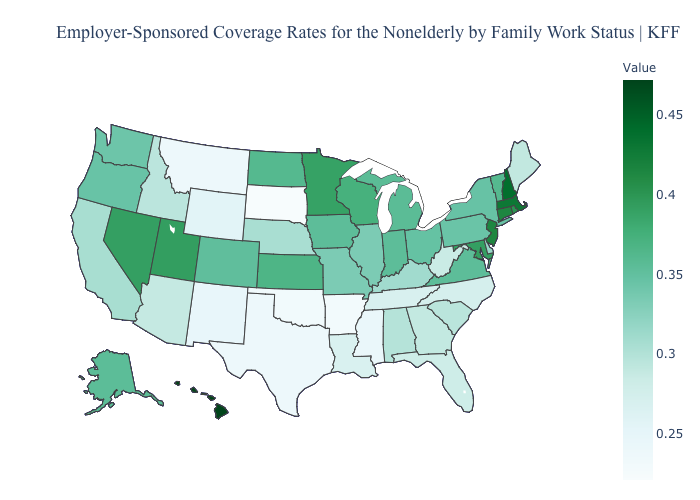Which states have the lowest value in the USA?
Quick response, please. South Dakota. Does South Dakota have the lowest value in the USA?
Short answer required. Yes. Among the states that border Missouri , does Oklahoma have the highest value?
Short answer required. No. Among the states that border Idaho , which have the lowest value?
Keep it brief. Montana. Is the legend a continuous bar?
Write a very short answer. Yes. Which states have the lowest value in the USA?
Short answer required. South Dakota. 